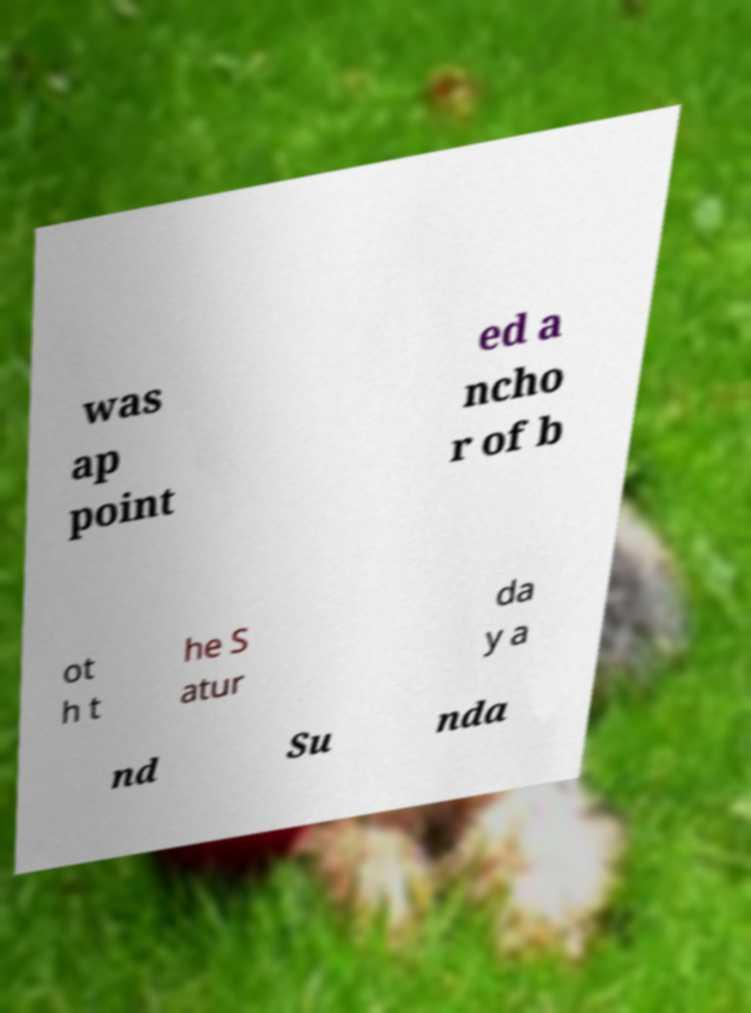Can you read and provide the text displayed in the image?This photo seems to have some interesting text. Can you extract and type it out for me? was ap point ed a ncho r of b ot h t he S atur da y a nd Su nda 